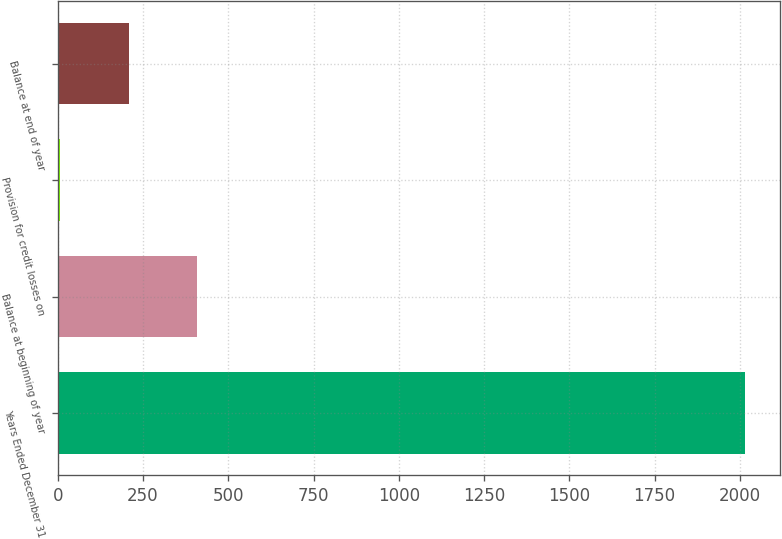Convert chart to OTSL. <chart><loc_0><loc_0><loc_500><loc_500><bar_chart><fcel>Years Ended December 31<fcel>Balance at beginning of year<fcel>Provision for credit losses on<fcel>Balance at end of year<nl><fcel>2016<fcel>408.8<fcel>7<fcel>207.9<nl></chart> 